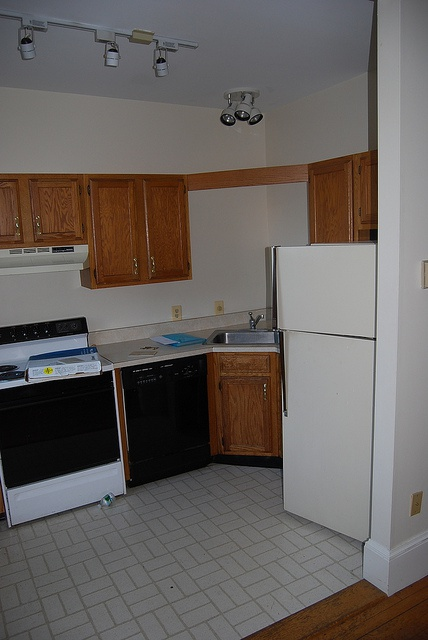Describe the objects in this image and their specific colors. I can see refrigerator in gray, darkgray, and black tones, oven in gray and black tones, book in gray, darkgray, and navy tones, sink in gray and black tones, and book in gray, blue, and darkblue tones in this image. 